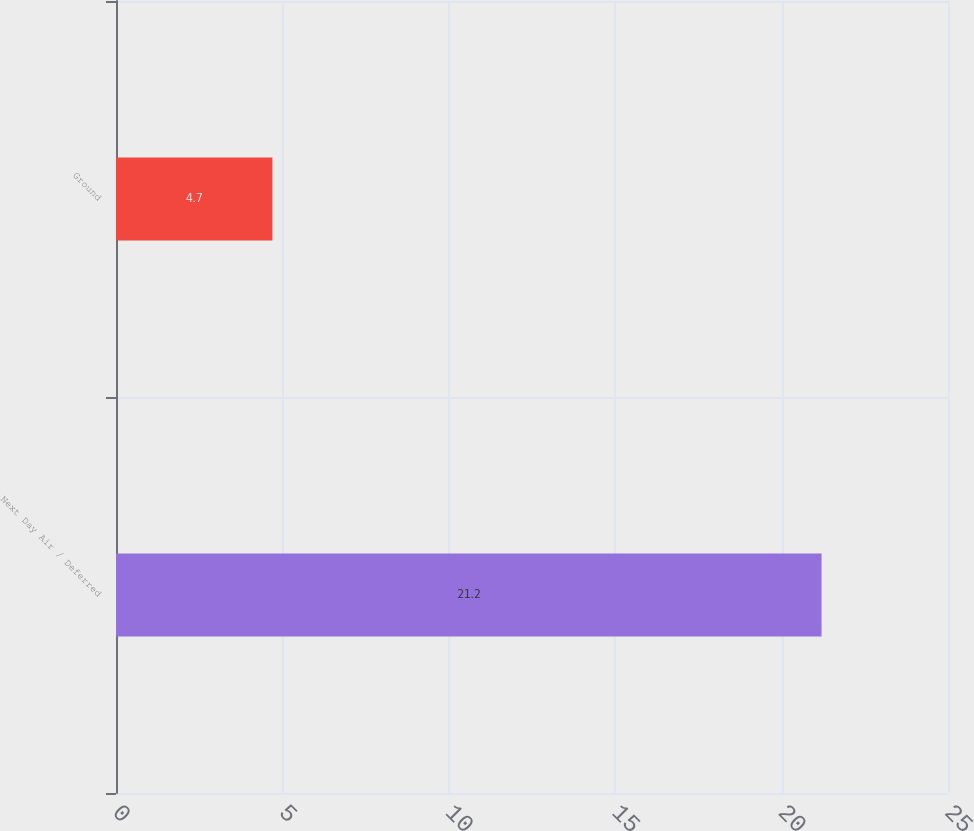Convert chart. <chart><loc_0><loc_0><loc_500><loc_500><bar_chart><fcel>Next Day Air / Deferred<fcel>Ground<nl><fcel>21.2<fcel>4.7<nl></chart> 